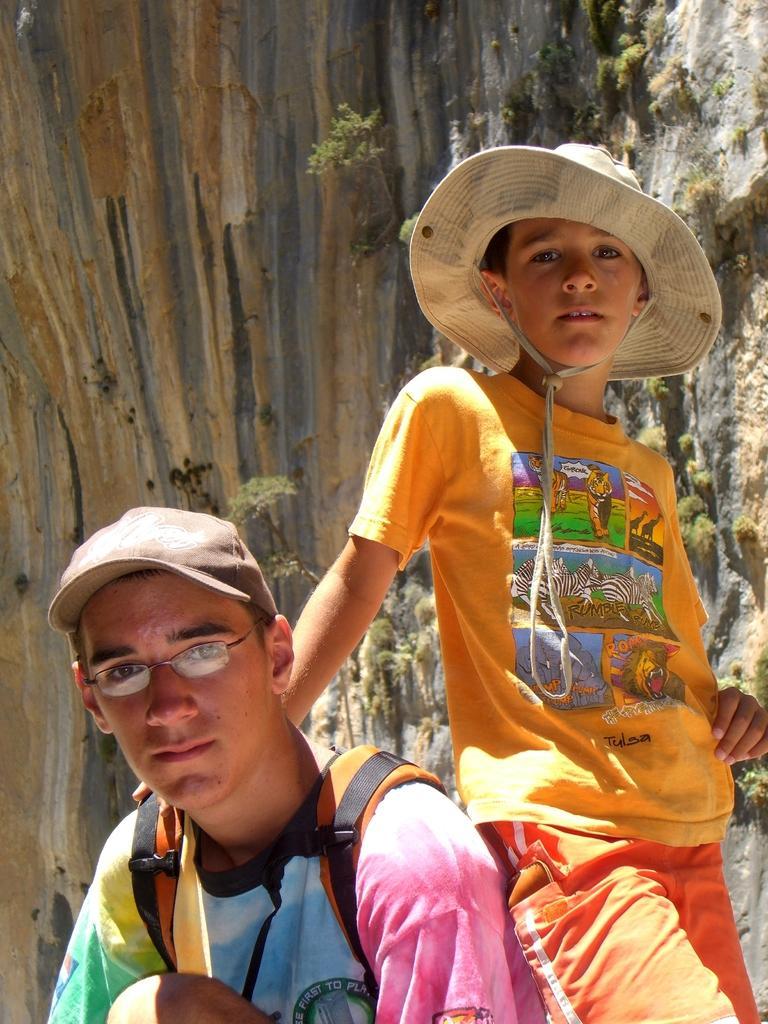How would you summarize this image in a sentence or two? In this image, we can see people and are wearing caps, one of them is wearing glasses and a bag. In the background, there is a rock and a tree trunk. 